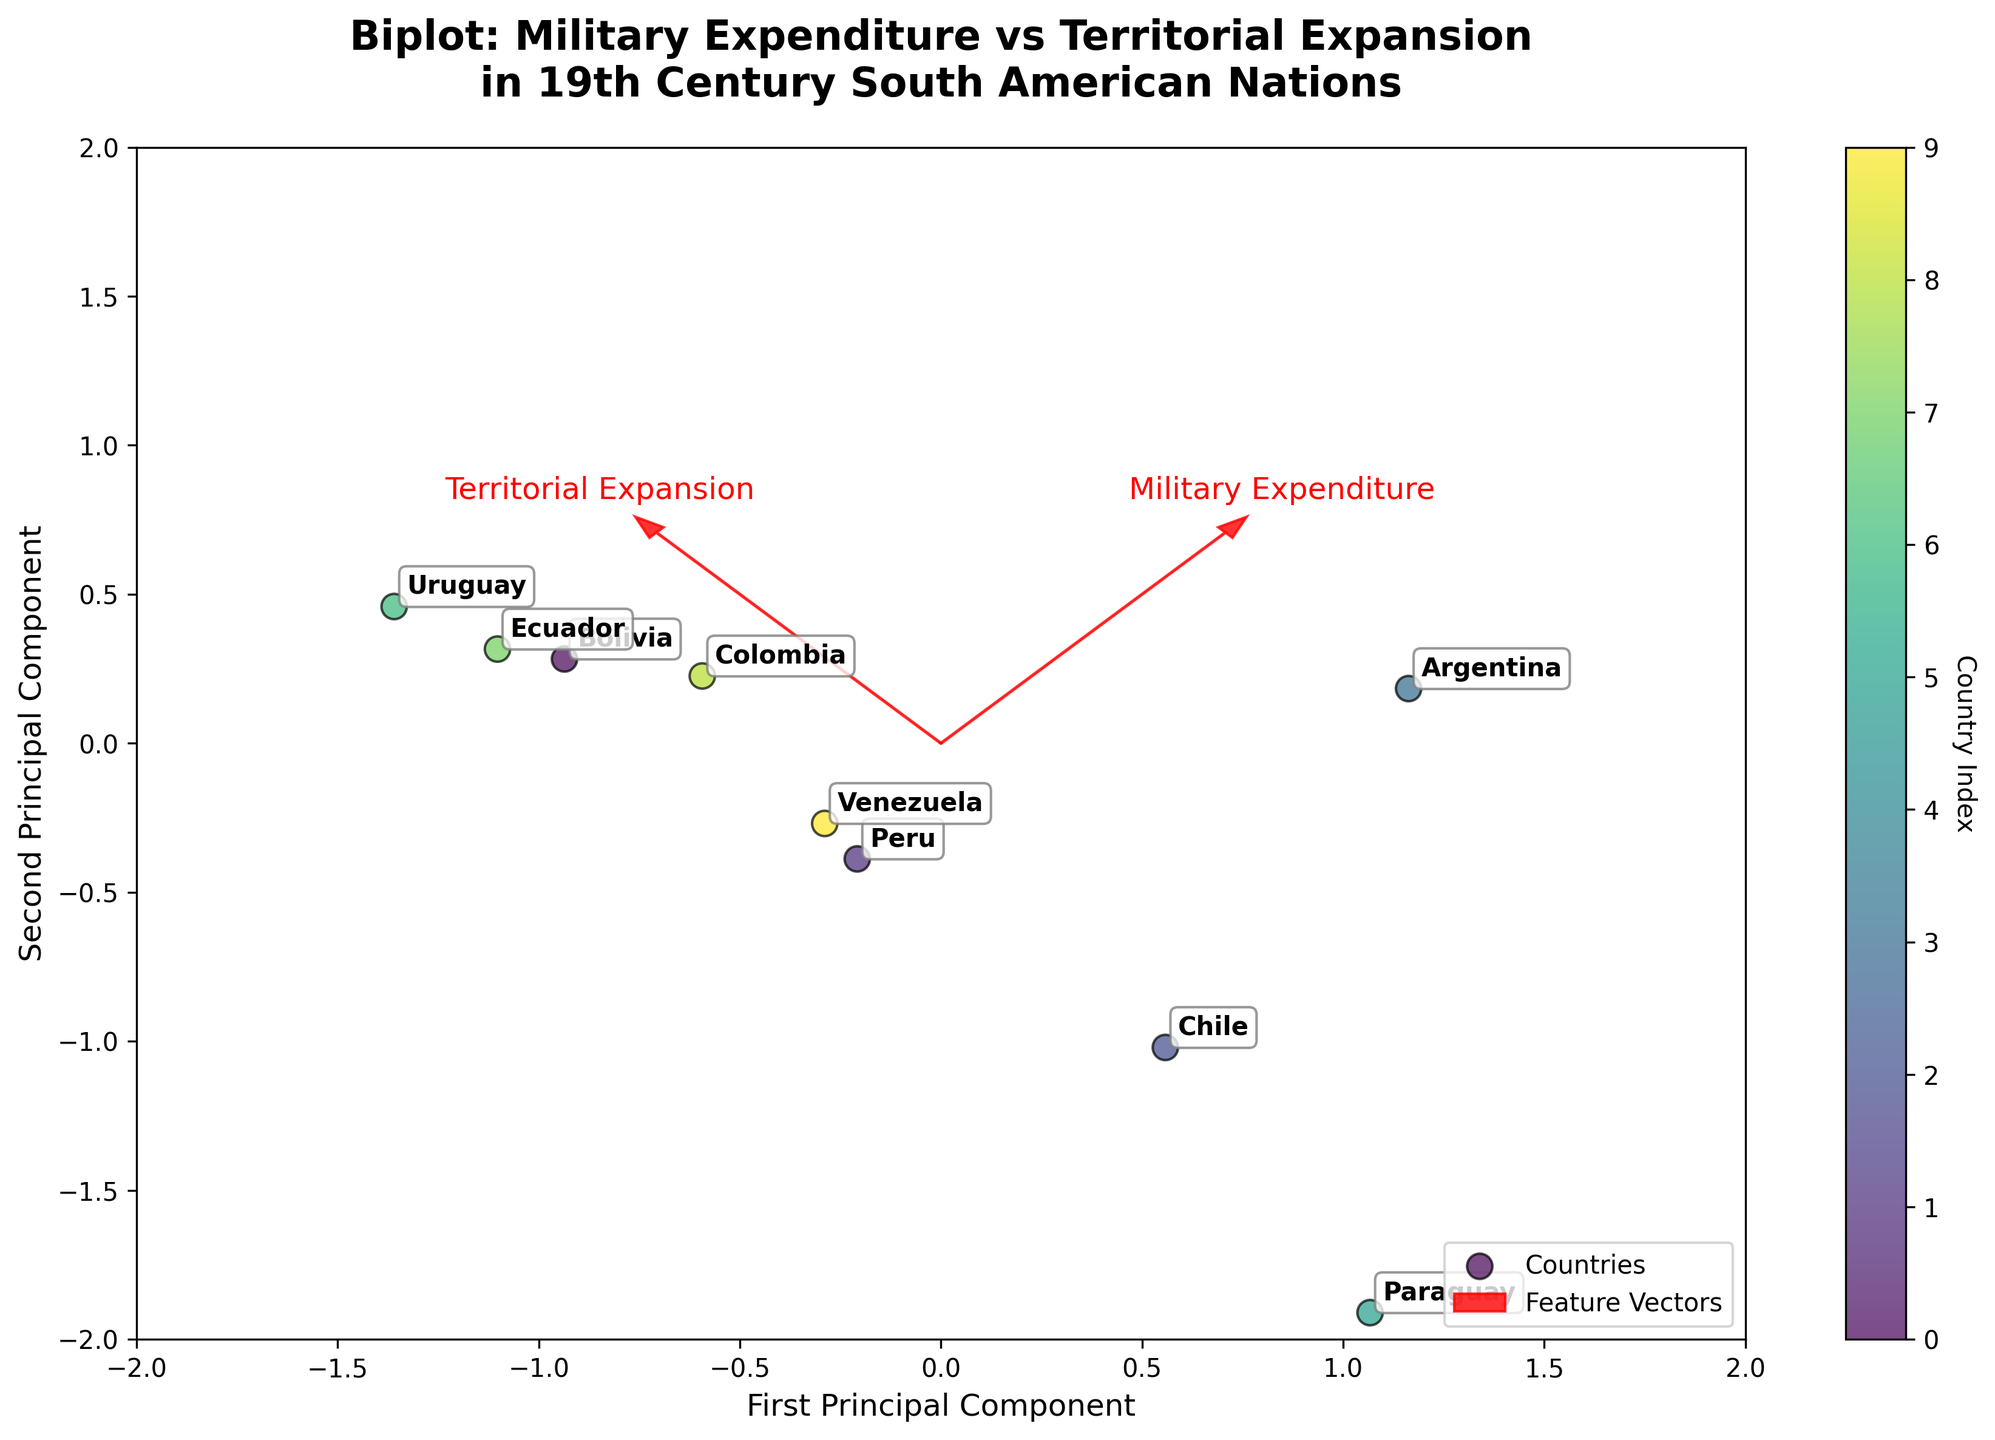What's the title of the figure? The title is prominently displayed at the top of the figure.
Answer: Biplot: Military Expenditure vs Territorial Expansion in 19th Century South American Nations How many countries are represented in the biplot? The number of data points (marked with different colors and labeled with country names) in the scatter plot can be counted.
Answer: 10 Which country has the highest military expenditure as a percentage of GDP? Locate the countries on the plot and refer to the annotations to find which one is furthest along the vector labeled 'Military Expenditure'.
Answer: Paraguay Which two countries have similar territorial expansion as per the biplot? Identify countries that are close to each other along the vector labeled 'Territorial Expansion'.
Answer: Peru and Venezuela Compare the military expenditure of Chile and Uruguay. Which one is higher? Locate Chile and Uruguay on the biplot and check their positioning along the 'Military Expenditure' vector.
Answer: Chile Among Brazil, Paraguay, and Bolivia, which country has the largest territorial expansion? Find Brazil, Paraguay, and Bolivia on the plot and compare their positioning along the vector labeled 'Territorial Expansion'.
Answer: Brazil Is there a general trend between military expenditure and territorial expansion in the figure? Analyze the direction and position of the feature vectors for 'Military Expenditure' and 'Territorial Expansion' to determine if they align or diverge.
Answer: No clear trend What feature explains most of the variance in the first principal component? The length and direction of the arrows representing feature vectors can be used to determine which feature influences the first principal component more.
Answer: Territorial Expansion Which country is an outlier in terms of military expenditure? Identify any country that is significantly distant along the 'Military Expenditure' vector compared to others.
Answer: Paraguay Are there any countries that show low values in both military expenditure and territorial expansion? Locate the countries that are closest to the origin (0,0) on both principal components.
Answer: Uruguay 